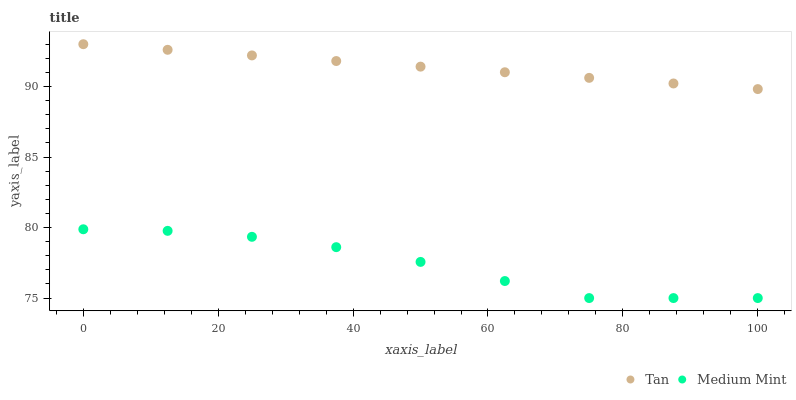Does Medium Mint have the minimum area under the curve?
Answer yes or no. Yes. Does Tan have the maximum area under the curve?
Answer yes or no. Yes. Does Tan have the minimum area under the curve?
Answer yes or no. No. Is Tan the smoothest?
Answer yes or no. Yes. Is Medium Mint the roughest?
Answer yes or no. Yes. Is Tan the roughest?
Answer yes or no. No. Does Medium Mint have the lowest value?
Answer yes or no. Yes. Does Tan have the lowest value?
Answer yes or no. No. Does Tan have the highest value?
Answer yes or no. Yes. Is Medium Mint less than Tan?
Answer yes or no. Yes. Is Tan greater than Medium Mint?
Answer yes or no. Yes. Does Medium Mint intersect Tan?
Answer yes or no. No. 